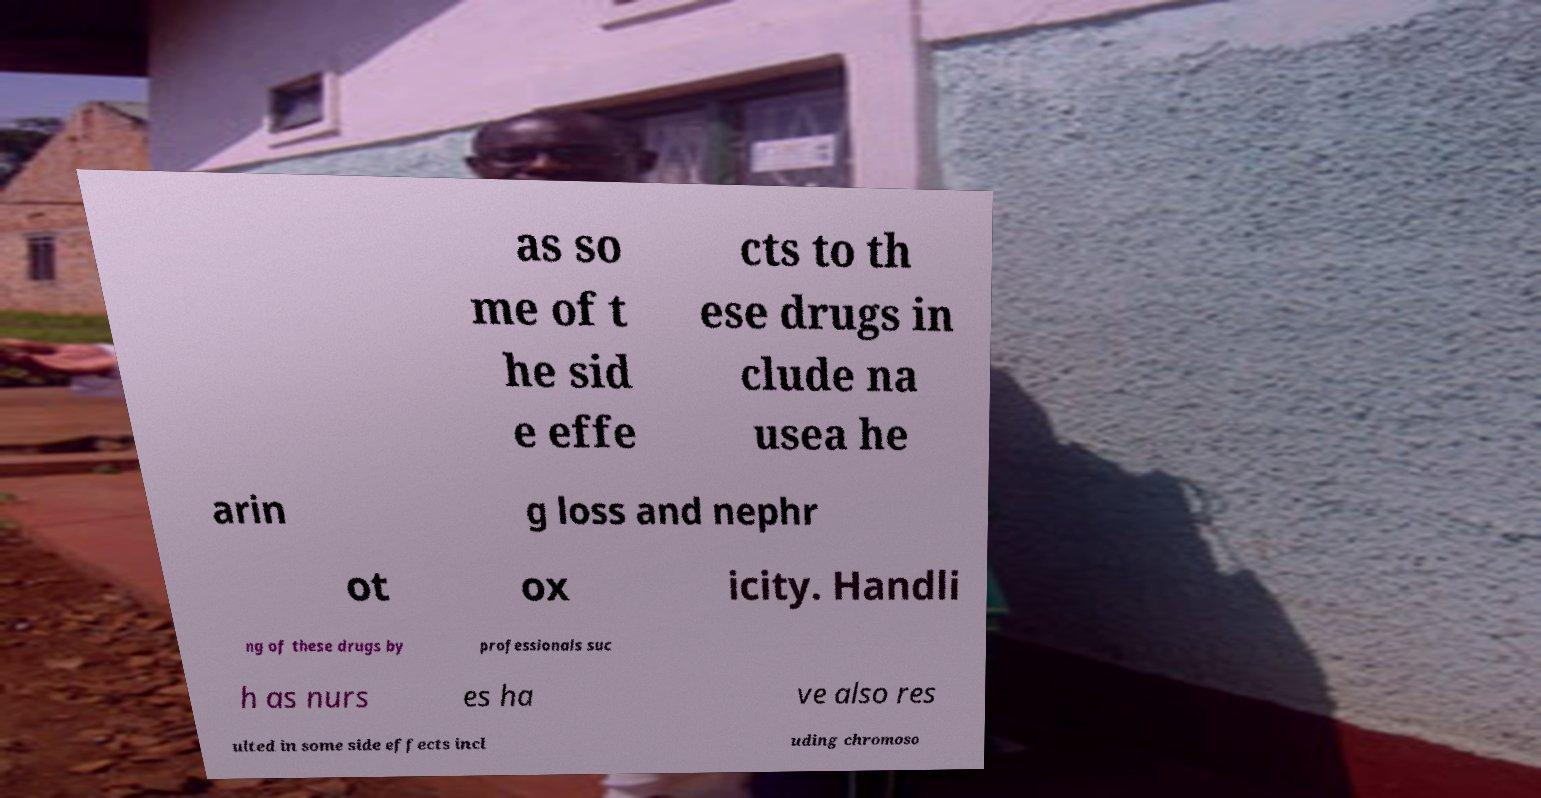Can you read and provide the text displayed in the image?This photo seems to have some interesting text. Can you extract and type it out for me? as so me of t he sid e effe cts to th ese drugs in clude na usea he arin g loss and nephr ot ox icity. Handli ng of these drugs by professionals suc h as nurs es ha ve also res ulted in some side effects incl uding chromoso 